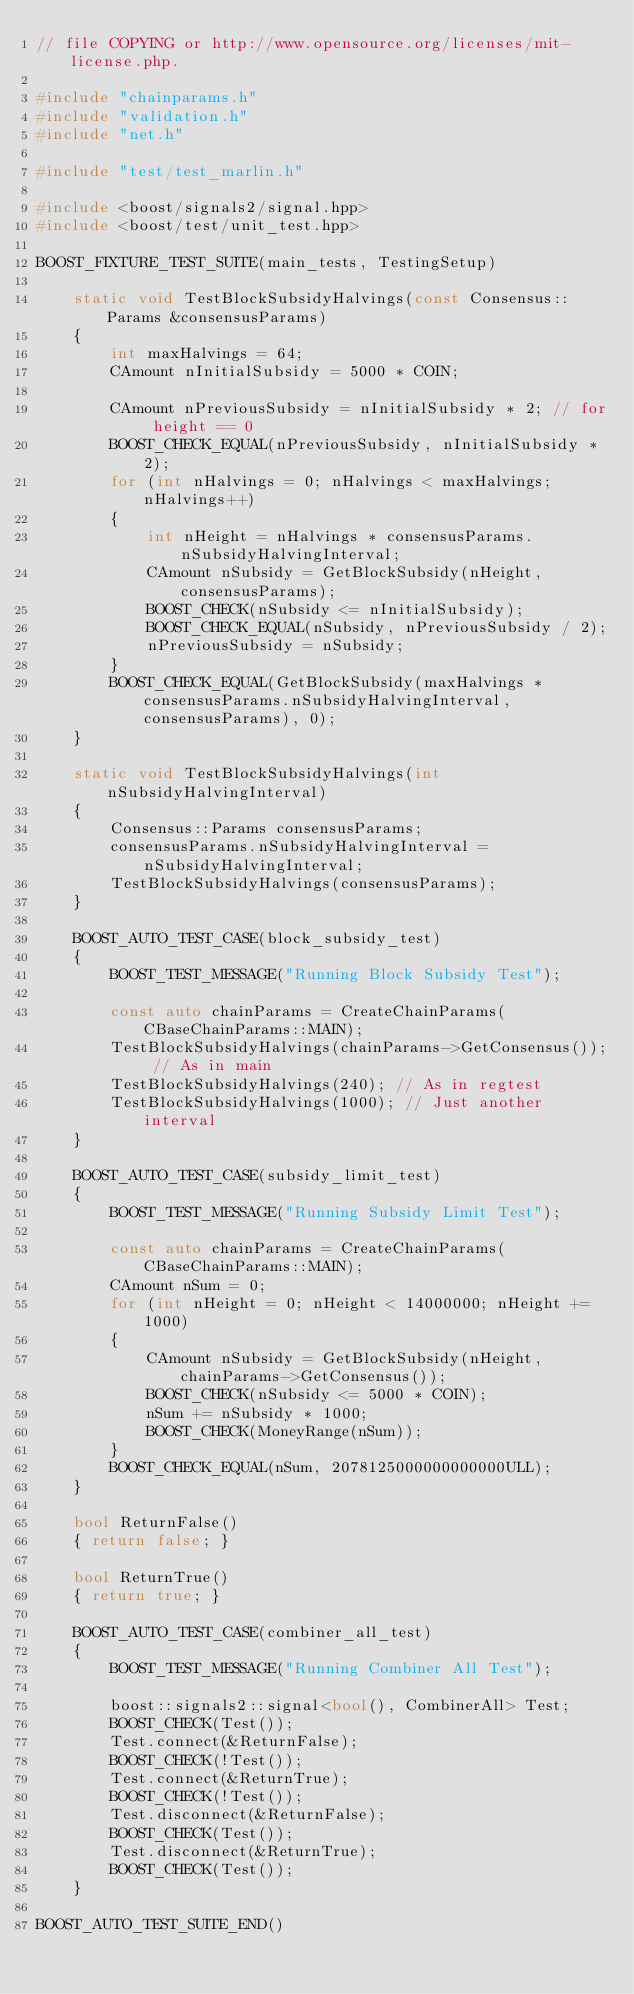Convert code to text. <code><loc_0><loc_0><loc_500><loc_500><_C++_>// file COPYING or http://www.opensource.org/licenses/mit-license.php.

#include "chainparams.h"
#include "validation.h"
#include "net.h"

#include "test/test_marlin.h"

#include <boost/signals2/signal.hpp>
#include <boost/test/unit_test.hpp>

BOOST_FIXTURE_TEST_SUITE(main_tests, TestingSetup)

    static void TestBlockSubsidyHalvings(const Consensus::Params &consensusParams)
    {
        int maxHalvings = 64;
        CAmount nInitialSubsidy = 5000 * COIN;

        CAmount nPreviousSubsidy = nInitialSubsidy * 2; // for height == 0
        BOOST_CHECK_EQUAL(nPreviousSubsidy, nInitialSubsidy * 2);
        for (int nHalvings = 0; nHalvings < maxHalvings; nHalvings++)
        {
            int nHeight = nHalvings * consensusParams.nSubsidyHalvingInterval;
            CAmount nSubsidy = GetBlockSubsidy(nHeight, consensusParams);
            BOOST_CHECK(nSubsidy <= nInitialSubsidy);
            BOOST_CHECK_EQUAL(nSubsidy, nPreviousSubsidy / 2);
            nPreviousSubsidy = nSubsidy;
        }
        BOOST_CHECK_EQUAL(GetBlockSubsidy(maxHalvings * consensusParams.nSubsidyHalvingInterval, consensusParams), 0);
    }

    static void TestBlockSubsidyHalvings(int nSubsidyHalvingInterval)
    {
        Consensus::Params consensusParams;
        consensusParams.nSubsidyHalvingInterval = nSubsidyHalvingInterval;
        TestBlockSubsidyHalvings(consensusParams);
    }

    BOOST_AUTO_TEST_CASE(block_subsidy_test)
    {
        BOOST_TEST_MESSAGE("Running Block Subsidy Test");

        const auto chainParams = CreateChainParams(CBaseChainParams::MAIN);
        TestBlockSubsidyHalvings(chainParams->GetConsensus()); // As in main
        TestBlockSubsidyHalvings(240); // As in regtest
        TestBlockSubsidyHalvings(1000); // Just another interval
    }

    BOOST_AUTO_TEST_CASE(subsidy_limit_test)
    {
        BOOST_TEST_MESSAGE("Running Subsidy Limit Test");

        const auto chainParams = CreateChainParams(CBaseChainParams::MAIN);
        CAmount nSum = 0;
        for (int nHeight = 0; nHeight < 14000000; nHeight += 1000)
        {
            CAmount nSubsidy = GetBlockSubsidy(nHeight, chainParams->GetConsensus());
            BOOST_CHECK(nSubsidy <= 5000 * COIN);
            nSum += nSubsidy * 1000;
            BOOST_CHECK(MoneyRange(nSum));
        }
        BOOST_CHECK_EQUAL(nSum, 2078125000000000000ULL);
    }

    bool ReturnFalse()
    { return false; }

    bool ReturnTrue()
    { return true; }

    BOOST_AUTO_TEST_CASE(combiner_all_test)
    {
        BOOST_TEST_MESSAGE("Running Combiner All Test");

        boost::signals2::signal<bool(), CombinerAll> Test;
        BOOST_CHECK(Test());
        Test.connect(&ReturnFalse);
        BOOST_CHECK(!Test());
        Test.connect(&ReturnTrue);
        BOOST_CHECK(!Test());
        Test.disconnect(&ReturnFalse);
        BOOST_CHECK(Test());
        Test.disconnect(&ReturnTrue);
        BOOST_CHECK(Test());
    }

BOOST_AUTO_TEST_SUITE_END()
</code> 